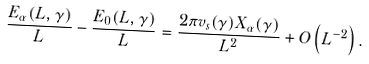<formula> <loc_0><loc_0><loc_500><loc_500>\frac { E _ { \alpha } ( L , \gamma ) } { L } - \frac { E _ { 0 } ( L , \gamma ) } { L } = \frac { 2 \pi v _ { s } ( \gamma ) X _ { \alpha } ( \gamma ) } { L ^ { 2 } } + O \left ( L ^ { - 2 } \right ) .</formula> 